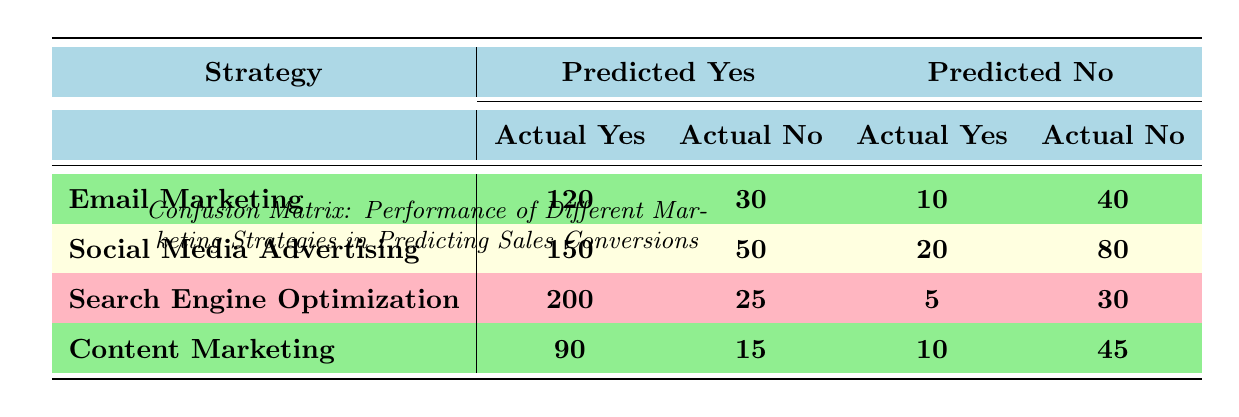What is the count of actual conversions predicted as "Yes" for Email Marketing? The table indicates that for Email Marketing, the count of actual conversions predicted as "Yes" is 120.
Answer: 120 What is the total count of wrong predictions (false positives and false negatives) for Social Media Advertising? For Social Media Advertising, the false positives (predicted Yes but actual No) count is 50, and the false negatives (predicted No but actual Yes) count is 20. Therefore, the total count of wrong predictions is 50 + 20 = 70.
Answer: 70 Is the count of actual No conversions predicted as No greater for Content Marketing compared to Search Engine Optimization? The count for Content Marketing is 45 (predicted No, actual No) and for Search Engine Optimization is 30 (predicted No, actual No). Since 45 is greater than 30, the answer is yes.
Answer: Yes What is the total count of conversions (both Yes and No) predicted by Search Engine Optimization? Adding up all counts for Search Engine Optimization: 200 (Yes, Yes) + 25 (Yes, No) + 5 (No, Yes) + 30 (No, No) gives a total of 200 + 25 + 5 + 30 = 260.
Answer: 260 Which marketing strategy had the highest number of actual Yes conversions predicted as Yes? The strategy that had the highest number is Search Engine Optimization with a count of 200 actual Yes conversions predicted as Yes.
Answer: Search Engine Optimization What is the difference in predicted Yes and No actual conversions for Content Marketing? For Content Marketing, the count of predicted Yes and actual Yes is 90, and the predicted No and actual No is 45. The difference is 90 - 45 = 45.
Answer: 45 What percentage of actual Yes conversions did Email Marketing accurately predict? Email Marketing accurately predicted 120 out of a total of (120 + 10 = 130) actual Yes conversions. The percentage is (120/130) * 100 = 92.31%.
Answer: 92.31% Are there more total conversions for Social Media Advertising than for Content Marketing? The total conversions for Social Media Advertising is 150 + 50 + 20 + 80 = 300, while for Content Marketing it is 90 + 15 + 10 + 45 = 160. Since 300 > 160, the answer is yes.
Answer: Yes 